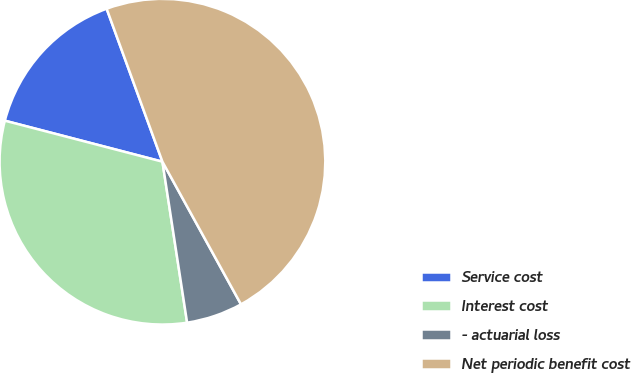<chart> <loc_0><loc_0><loc_500><loc_500><pie_chart><fcel>Service cost<fcel>Interest cost<fcel>- actuarial loss<fcel>Net periodic benefit cost<nl><fcel>15.38%<fcel>31.47%<fcel>5.59%<fcel>47.55%<nl></chart> 